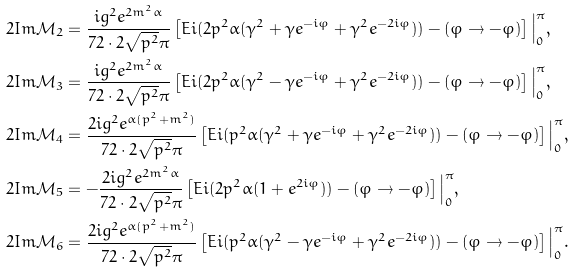Convert formula to latex. <formula><loc_0><loc_0><loc_500><loc_500>2 I m \mathcal { M } _ { 2 } & = \frac { i g ^ { 2 } e ^ { 2 m ^ { 2 } \alpha } } { 7 2 \cdot 2 \sqrt { p ^ { 2 } } \pi } \left [ E i ( 2 p ^ { 2 } \alpha ( \gamma ^ { 2 } + \gamma e ^ { - i \varphi } + \gamma ^ { 2 } e ^ { - 2 i \varphi } ) ) - ( \varphi \rightarrow - \varphi ) \right ] \Big | _ { 0 } ^ { \pi } , \\ 2 I m \mathcal { M } _ { 3 } & = \frac { i g ^ { 2 } e ^ { 2 m ^ { 2 } \alpha } } { 7 2 \cdot 2 \sqrt { p ^ { 2 } } \pi } \left [ E i ( 2 p ^ { 2 } \alpha ( \gamma ^ { 2 } - \gamma e ^ { - i \varphi } + \gamma ^ { 2 } e ^ { - 2 i \varphi } ) ) - ( \varphi \rightarrow - \varphi ) \right ] \Big | _ { 0 } ^ { \pi } , \\ 2 I m \mathcal { M } _ { 4 } & = \frac { 2 i g ^ { 2 } e ^ { \alpha ( p ^ { 2 } + m ^ { 2 } ) } } { 7 2 \cdot 2 \sqrt { p ^ { 2 } } \pi } \left [ E i ( p ^ { 2 } \alpha ( \gamma ^ { 2 } + \gamma e ^ { - i \varphi } + \gamma ^ { 2 } e ^ { - 2 i \varphi } ) ) - ( \varphi \rightarrow - \varphi ) \right ] \Big | _ { 0 } ^ { \pi } , \\ 2 I m \mathcal { M } _ { 5 } & = - \frac { 2 i g ^ { 2 } e ^ { 2 m ^ { 2 } \alpha } } { 7 2 \cdot 2 \sqrt { p ^ { 2 } } \pi } \left [ E i ( 2 p ^ { 2 } \alpha ( 1 + e ^ { 2 i \varphi } ) ) - ( \varphi \rightarrow - \varphi ) \right ] \Big | _ { 0 } ^ { \pi } , \\ 2 I m \mathcal { M } _ { 6 } & = \frac { 2 i g ^ { 2 } e ^ { \alpha ( p ^ { 2 } + m ^ { 2 } ) } } { 7 2 \cdot 2 \sqrt { p ^ { 2 } } \pi } \left [ E i ( p ^ { 2 } \alpha ( \gamma ^ { 2 } - \gamma e ^ { - i \varphi } + \gamma ^ { 2 } e ^ { - 2 i \varphi } ) ) - ( \varphi \rightarrow - \varphi ) \right ] \Big | _ { 0 } ^ { \pi } .</formula> 